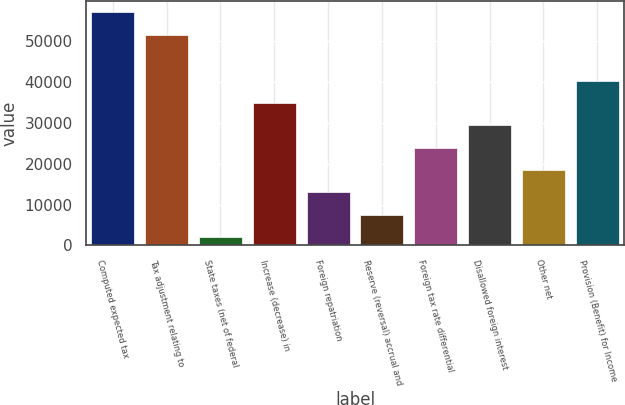Convert chart to OTSL. <chart><loc_0><loc_0><loc_500><loc_500><bar_chart><fcel>Computed expected tax<fcel>Tax adjustment relating to<fcel>State taxes (net of federal<fcel>Increase (decrease) in<fcel>Foreign repatriation<fcel>Reserve (reversal) accrual and<fcel>Foreign tax rate differential<fcel>Disallowed foreign interest<fcel>Other net<fcel>Provision (Benefit) for Income<nl><fcel>57095.6<fcel>51625<fcel>2017<fcel>34840.6<fcel>12958.2<fcel>7487.6<fcel>23899.4<fcel>29370<fcel>18428.8<fcel>40311.2<nl></chart> 